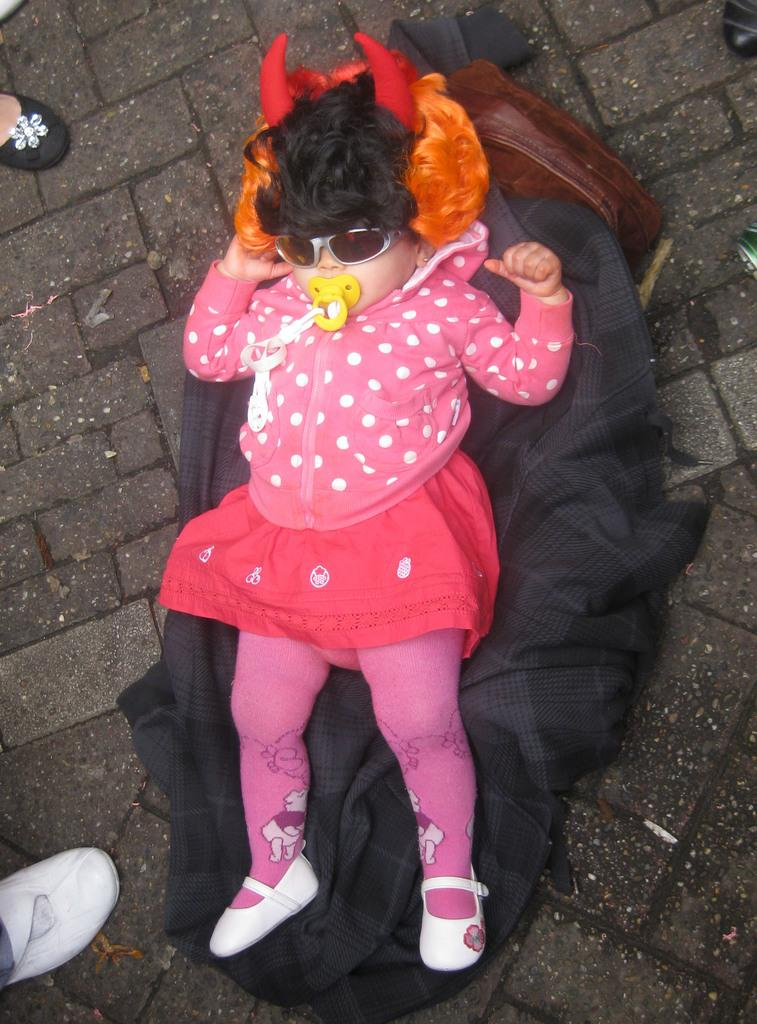Who is the main subject in the image? There is a baby girl in the image. What is the baby girl lying on? The baby girl is lying on a coat. Are there any other people in the image? Yes, there are people around the baby girl. What part of the people can be seen in the image? Only the feet of the people are visible in the image. What type of mine is visible in the image? There is no mine present in the image. What kind of lace can be seen on the baby girl's clothing? The image does not provide enough detail to determine if there is any lace on the baby girl's clothing. 